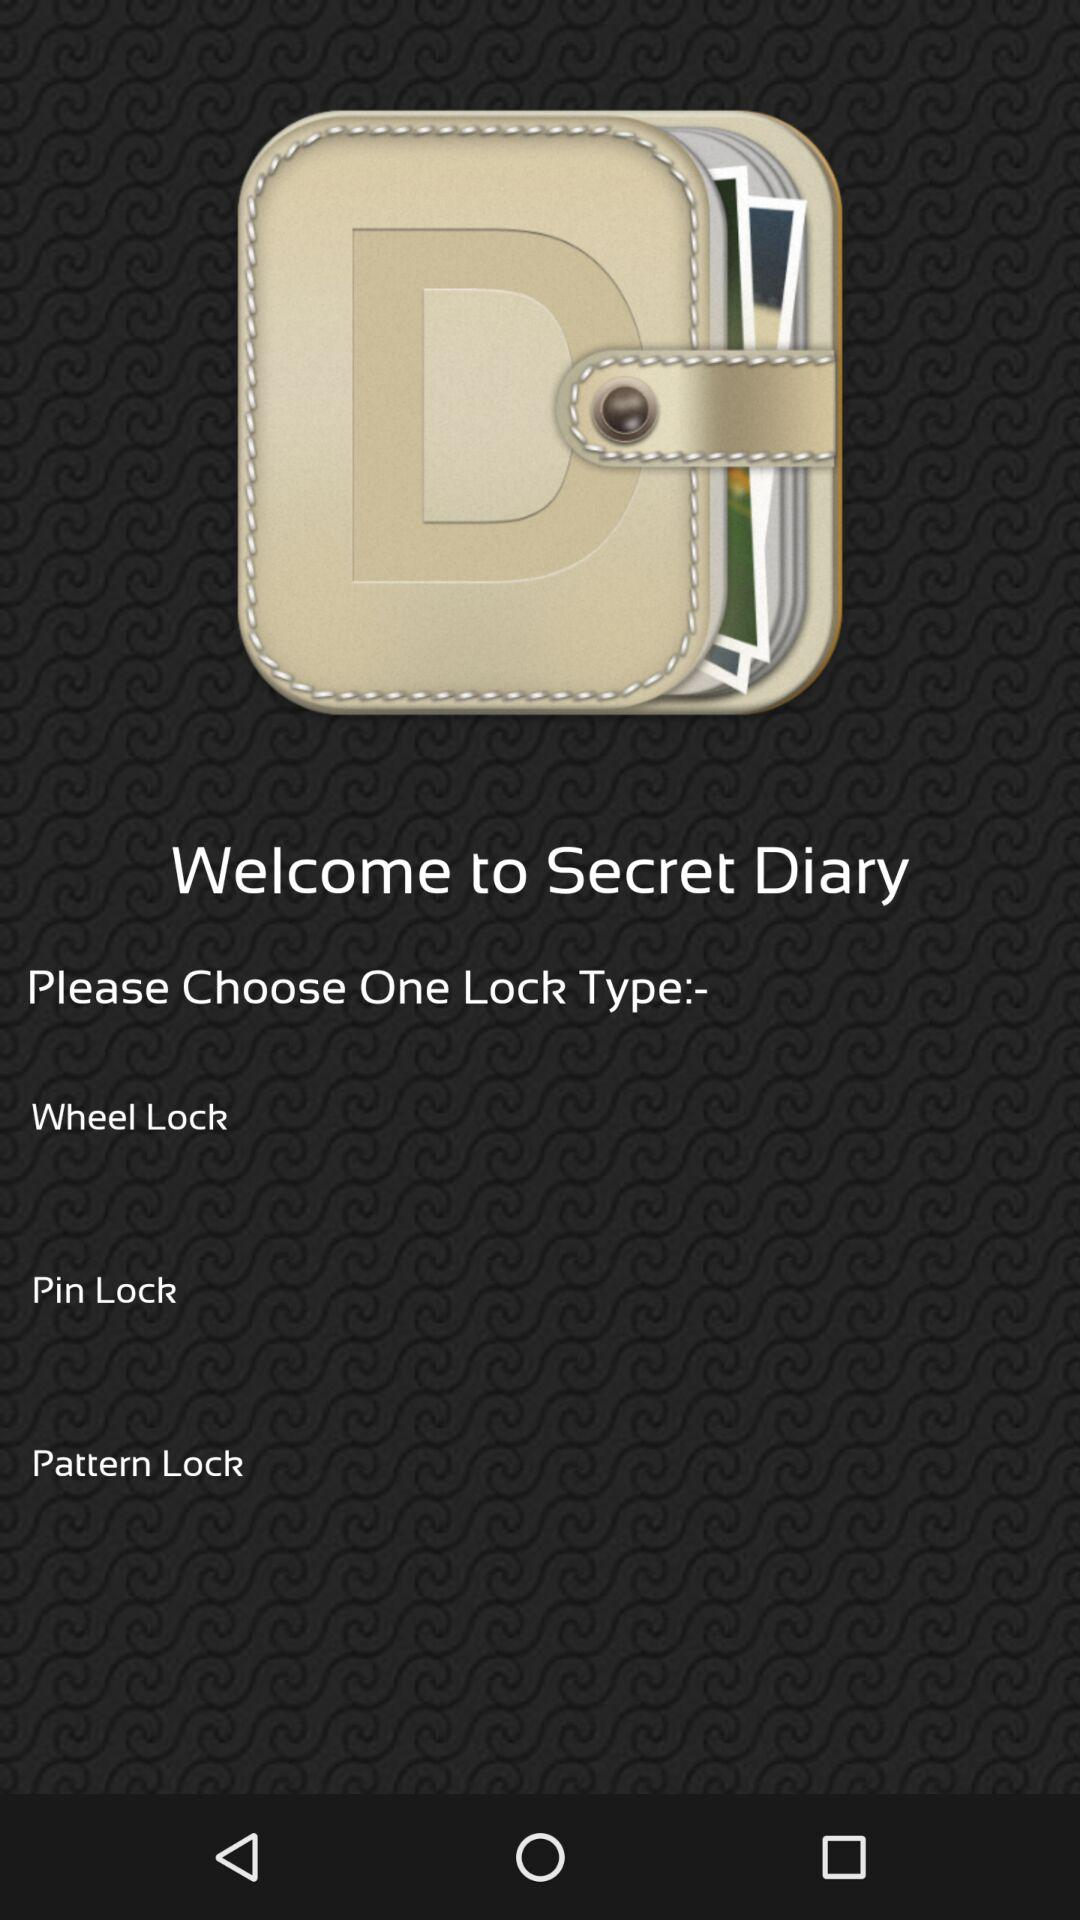How many lock types are available?
Answer the question using a single word or phrase. 3 